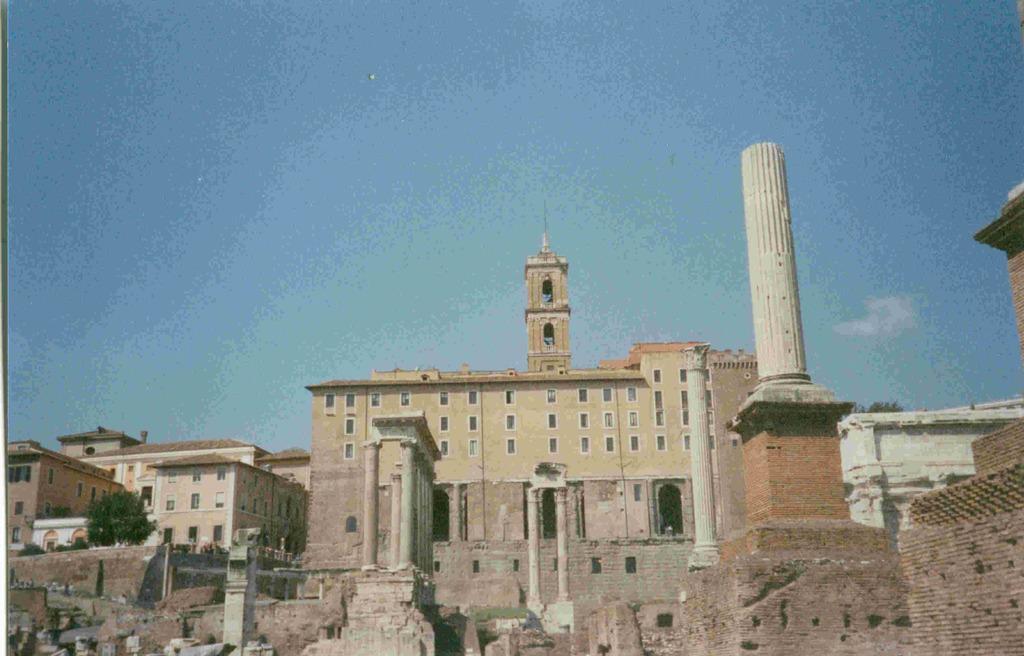Please provide a concise description of this image. In this image we can see a few buildings, there are some trees, windows, pillars and the wall, in the background we can see the sky with clouds. 